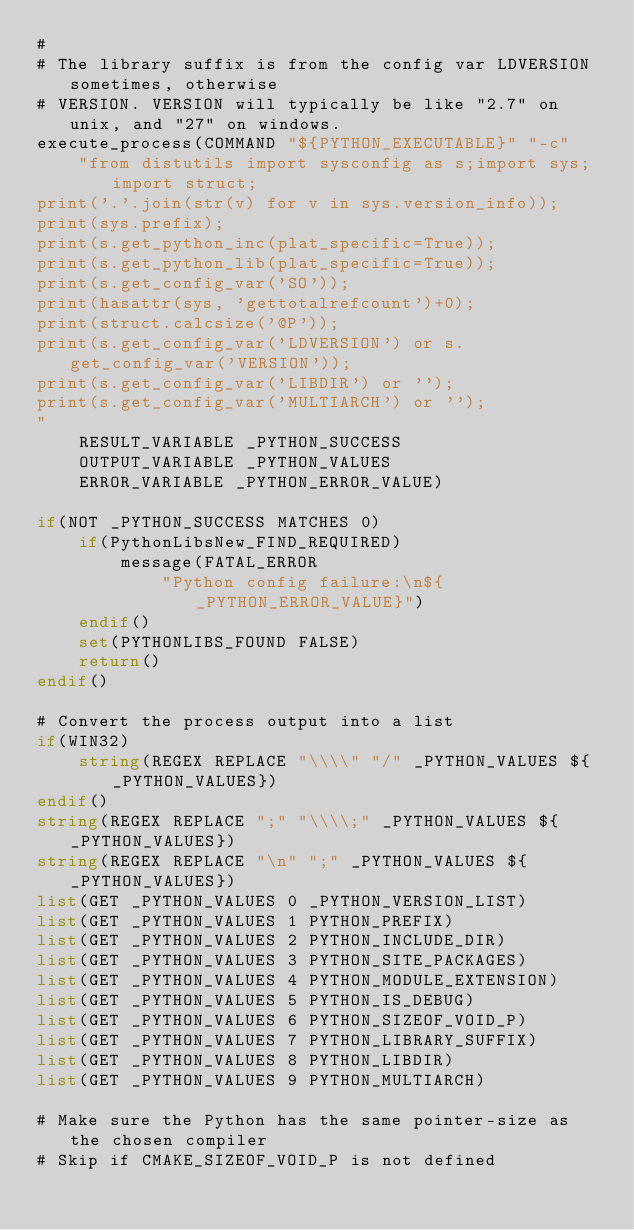Convert code to text. <code><loc_0><loc_0><loc_500><loc_500><_CMake_>#
# The library suffix is from the config var LDVERSION sometimes, otherwise
# VERSION. VERSION will typically be like "2.7" on unix, and "27" on windows.
execute_process(COMMAND "${PYTHON_EXECUTABLE}" "-c"
    "from distutils import sysconfig as s;import sys;import struct;
print('.'.join(str(v) for v in sys.version_info));
print(sys.prefix);
print(s.get_python_inc(plat_specific=True));
print(s.get_python_lib(plat_specific=True));
print(s.get_config_var('SO'));
print(hasattr(sys, 'gettotalrefcount')+0);
print(struct.calcsize('@P'));
print(s.get_config_var('LDVERSION') or s.get_config_var('VERSION'));
print(s.get_config_var('LIBDIR') or '');
print(s.get_config_var('MULTIARCH') or '');
"
    RESULT_VARIABLE _PYTHON_SUCCESS
    OUTPUT_VARIABLE _PYTHON_VALUES
    ERROR_VARIABLE _PYTHON_ERROR_VALUE)

if(NOT _PYTHON_SUCCESS MATCHES 0)
    if(PythonLibsNew_FIND_REQUIRED)
        message(FATAL_ERROR
            "Python config failure:\n${_PYTHON_ERROR_VALUE}")
    endif()
    set(PYTHONLIBS_FOUND FALSE)
    return()
endif()

# Convert the process output into a list
if(WIN32)
    string(REGEX REPLACE "\\\\" "/" _PYTHON_VALUES ${_PYTHON_VALUES})
endif()
string(REGEX REPLACE ";" "\\\\;" _PYTHON_VALUES ${_PYTHON_VALUES})
string(REGEX REPLACE "\n" ";" _PYTHON_VALUES ${_PYTHON_VALUES})
list(GET _PYTHON_VALUES 0 _PYTHON_VERSION_LIST)
list(GET _PYTHON_VALUES 1 PYTHON_PREFIX)
list(GET _PYTHON_VALUES 2 PYTHON_INCLUDE_DIR)
list(GET _PYTHON_VALUES 3 PYTHON_SITE_PACKAGES)
list(GET _PYTHON_VALUES 4 PYTHON_MODULE_EXTENSION)
list(GET _PYTHON_VALUES 5 PYTHON_IS_DEBUG)
list(GET _PYTHON_VALUES 6 PYTHON_SIZEOF_VOID_P)
list(GET _PYTHON_VALUES 7 PYTHON_LIBRARY_SUFFIX)
list(GET _PYTHON_VALUES 8 PYTHON_LIBDIR)
list(GET _PYTHON_VALUES 9 PYTHON_MULTIARCH)

# Make sure the Python has the same pointer-size as the chosen compiler
# Skip if CMAKE_SIZEOF_VOID_P is not defined</code> 